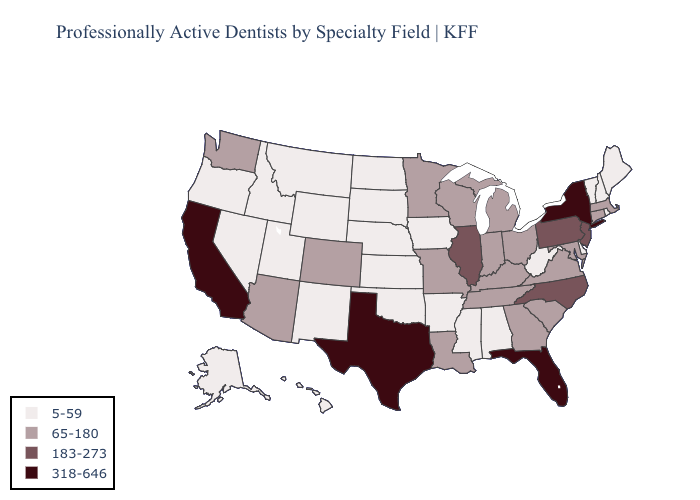Which states have the lowest value in the MidWest?
Concise answer only. Iowa, Kansas, Nebraska, North Dakota, South Dakota. What is the value of Nevada?
Be succinct. 5-59. Does Utah have the same value as Minnesota?
Be succinct. No. Does Nebraska have the same value as South Dakota?
Quick response, please. Yes. Which states have the lowest value in the MidWest?
Answer briefly. Iowa, Kansas, Nebraska, North Dakota, South Dakota. Name the states that have a value in the range 65-180?
Be succinct. Arizona, Colorado, Connecticut, Georgia, Indiana, Kentucky, Louisiana, Maryland, Massachusetts, Michigan, Minnesota, Missouri, Ohio, South Carolina, Tennessee, Virginia, Washington, Wisconsin. Name the states that have a value in the range 318-646?
Keep it brief. California, Florida, New York, Texas. Name the states that have a value in the range 5-59?
Give a very brief answer. Alabama, Alaska, Arkansas, Delaware, Hawaii, Idaho, Iowa, Kansas, Maine, Mississippi, Montana, Nebraska, Nevada, New Hampshire, New Mexico, North Dakota, Oklahoma, Oregon, Rhode Island, South Dakota, Utah, Vermont, West Virginia, Wyoming. Does Maryland have the highest value in the USA?
Keep it brief. No. Among the states that border Alabama , which have the lowest value?
Keep it brief. Mississippi. Among the states that border New Hampshire , does Maine have the highest value?
Give a very brief answer. No. What is the value of West Virginia?
Keep it brief. 5-59. What is the value of Mississippi?
Concise answer only. 5-59. What is the value of Wyoming?
Write a very short answer. 5-59. What is the highest value in the USA?
Be succinct. 318-646. 